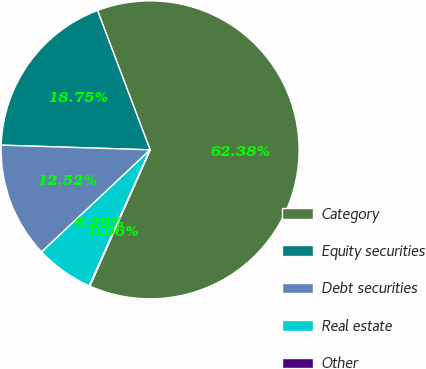Convert chart. <chart><loc_0><loc_0><loc_500><loc_500><pie_chart><fcel>Category<fcel>Equity securities<fcel>Debt securities<fcel>Real estate<fcel>Other<nl><fcel>62.37%<fcel>18.75%<fcel>12.52%<fcel>6.29%<fcel>0.06%<nl></chart> 